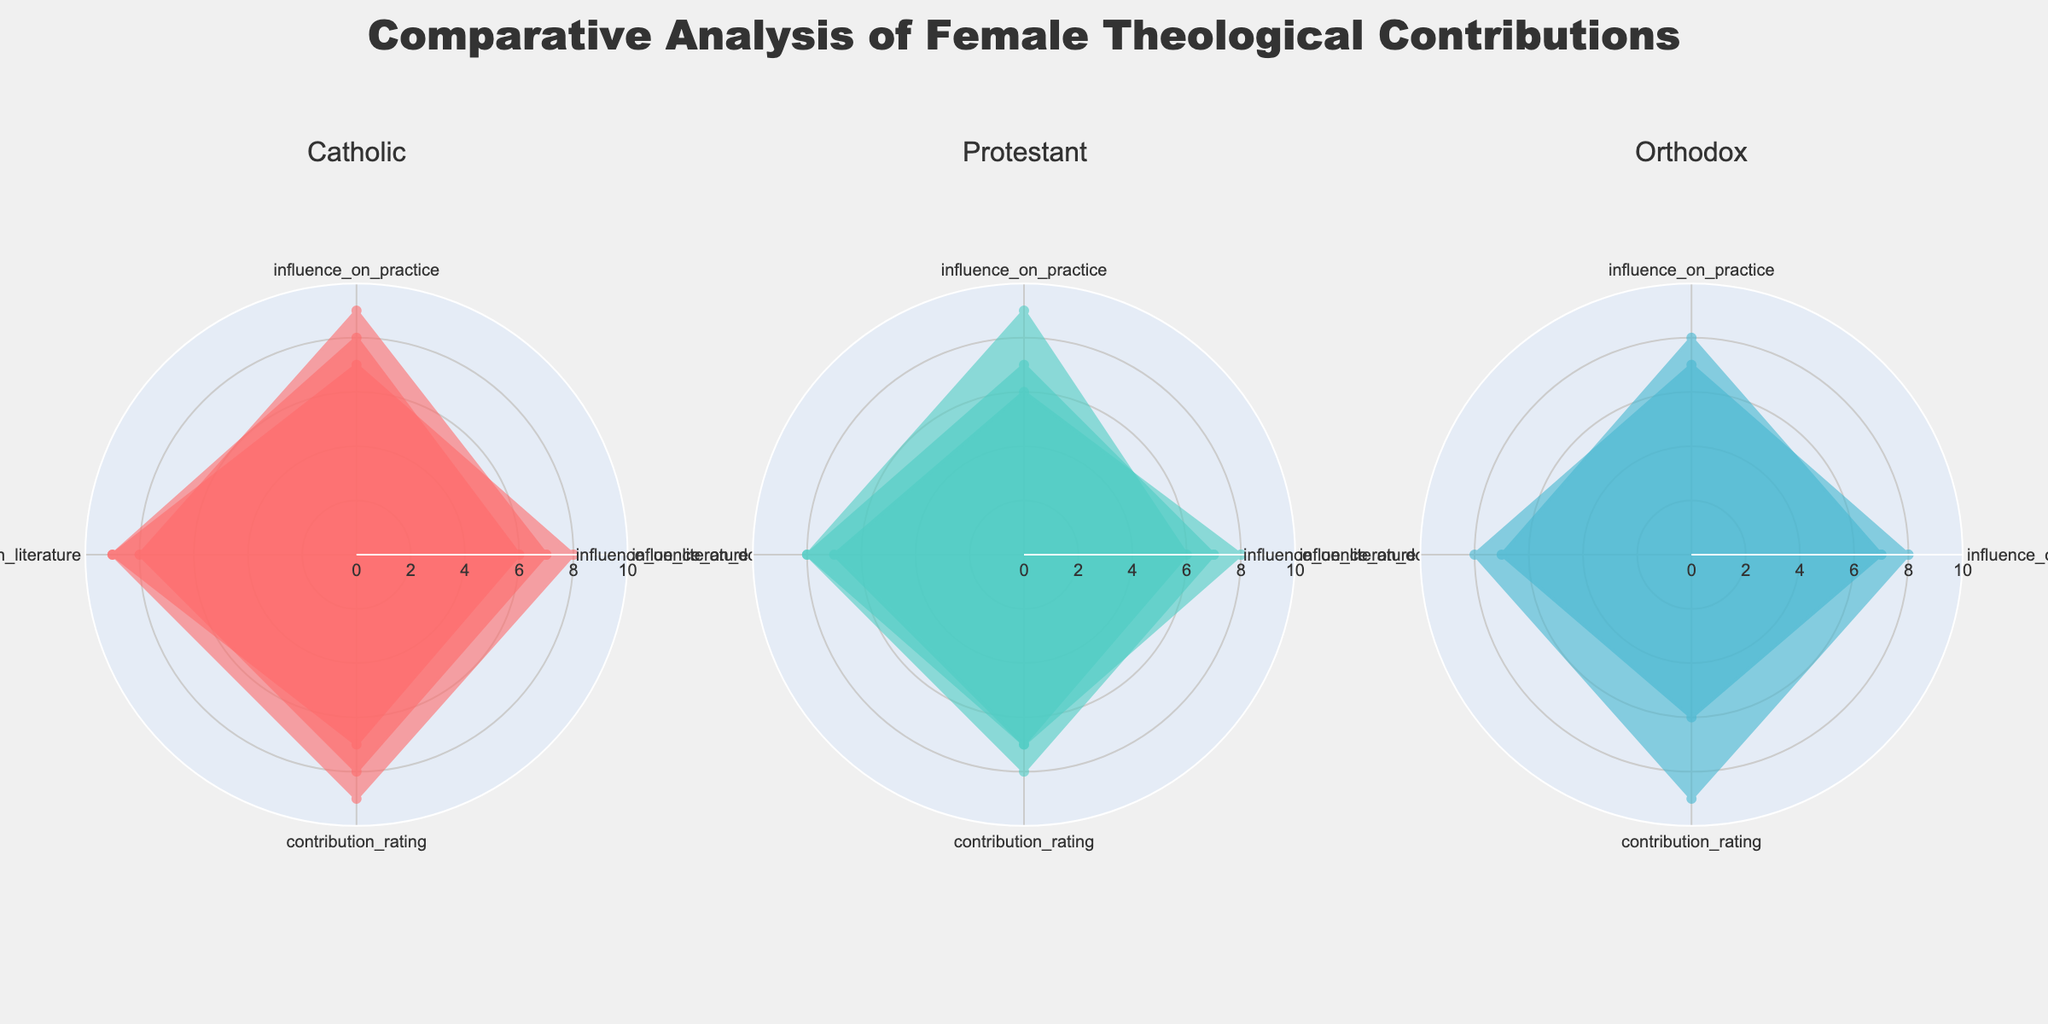What is the title of the plot? The title of the plot is prominently displayed at the top of the figure. It provides context on what the figure is about.
Answer: Comparative Analysis of Female Theological Contributions How many Christian traditions are compared in the subplots? The figure has three subplot titles, each representing a different Christian tradition.
Answer: Three Which theologian in the Catholic tradition has the highest contribution rating? The Catholic subplot shows different theologians' ratings. Hildegard of Bingen has the highest contribution rating of 9.
Answer: Hildegard of Bingen Which tradition has the theologian with the lowest influence on practice rating? By comparing the influence on practice ratings in each subplot, we see that Elizabeth Behr-Sigel in the Orthodox tradition has the lowest rating with a 6.
Answer: Orthodox Who has a higher influence on literature rating: Teresa of Ávila or Dorothy Day? In the Catholic subplot, Teresa of Ávila has an influence on literature rating of 8, while Dorothy Day has a rating of 9. Dorothy Day has a higher rating.
Answer: Dorothy Day Which theologian has the most balanced ratings across all categories? A balanced rating would mean that the values across doctrine, practice, literature, and contribution are similar. Anne Hutchinson in the Protestant tradition has ratings of 8, 7, 7, and 8, which are quite close to each other.
Answer: Anne Hutchinson What is the average contribution rating of the Protestant theologians? Adding the contribution ratings for Protestant theologians: (8 + 7 + 7) = 22, then divide by the number of theologians (3).
Answer: 7.33 Which Orthodox theologian has a higher influence on literature: Macrina the Younger or Elizabeth Behr-Sigel? By observing the ratings in the Orthodox subplot, Macrina the Younger has a literature influence rating of 8, while Elizabeth Behr-Sigel has a rating of 7.
Answer: Macrina the Younger Who among the theologians has the highest influence on doctrine across all traditions and centuries? By examining each subplot for the highest influence on doctrine rating, Hildegard of Bingen in the Catholic tradition has a rating of 9, which is the highest.
Answer: Hildegard of Bingen In which tradition is the 20th century the most represented in the subplots? By counting the number of theologians from the 20th century in each tradition's subplot, the Catholic tradition has two theologians from the 20th century, while the Protestant and Orthodox traditions each have one.
Answer: Catholic 